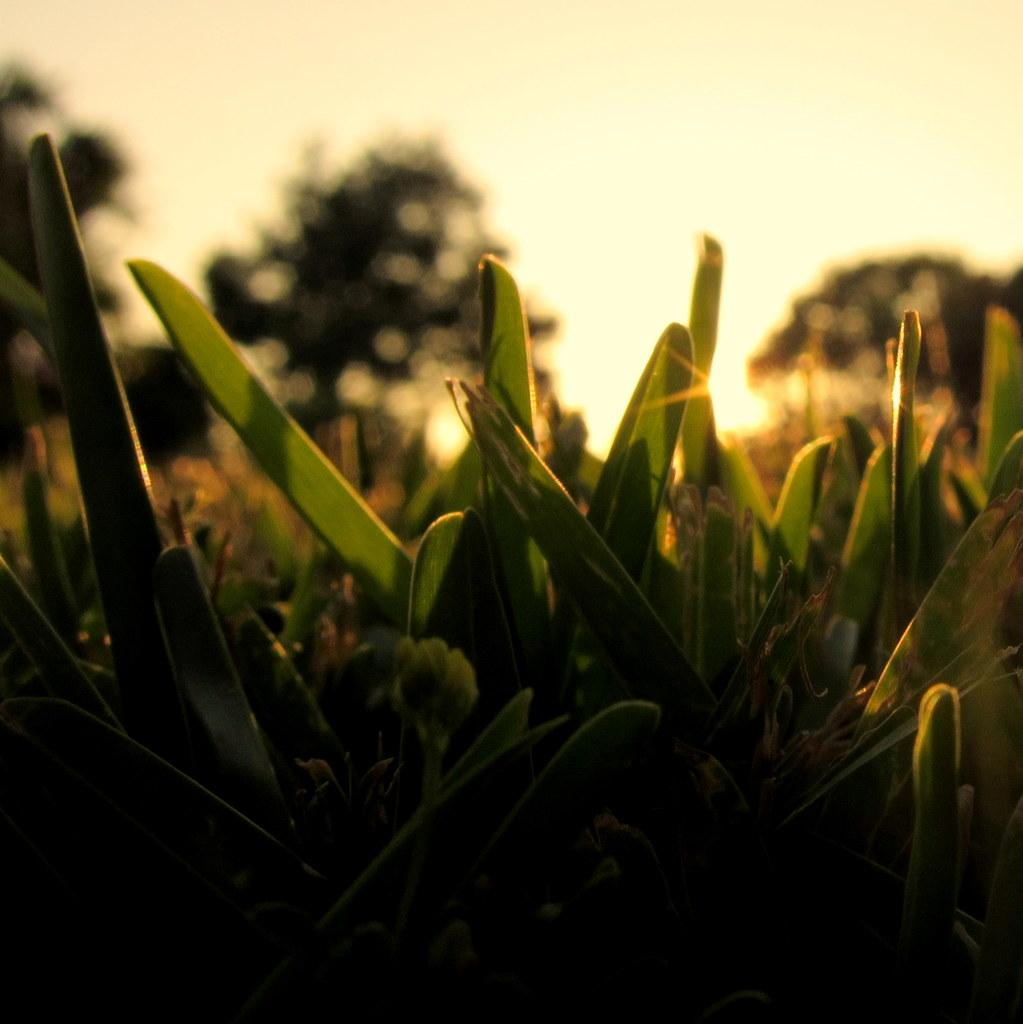What type of vegetation can be seen in the image? There are plants and trees in the image. What part of the natural environment is visible in the image? The sky is visible in the image. What type of camera can be seen in the image? There is no camera present in the image. What emotion is displayed by the plants in the image? Plants do not have emotions, so it is not possible to determine any emotion from the image. 